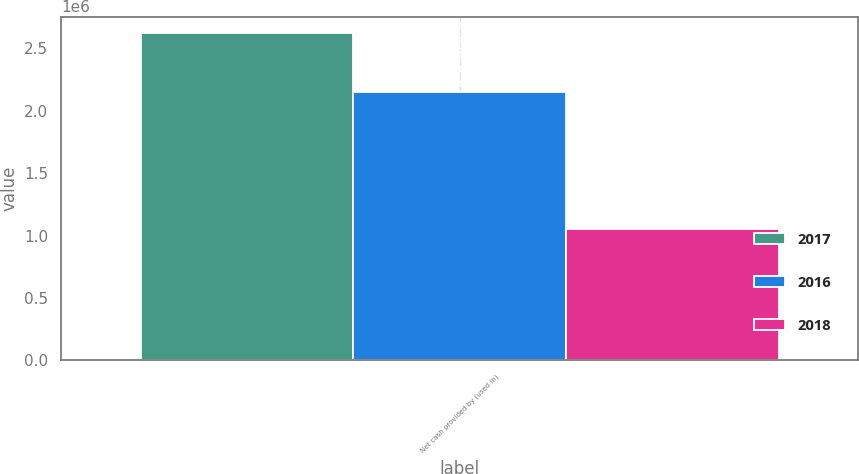Convert chart to OTSL. <chart><loc_0><loc_0><loc_500><loc_500><stacked_bar_chart><ecel><fcel>Net cash provided by (used in)<nl><fcel>2017<fcel>2.62054e+06<nl><fcel>2016<fcel>2.14846e+06<nl><fcel>2018<fcel>1.05426e+06<nl></chart> 